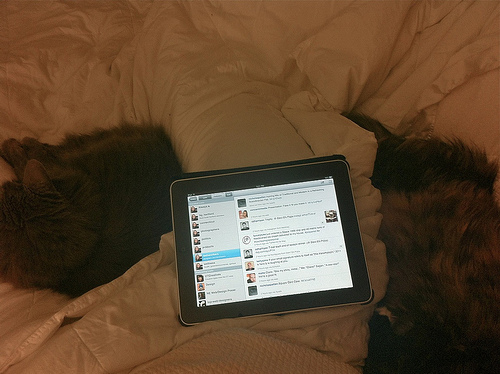<image>
Is the cat next to the ipad? Yes. The cat is positioned adjacent to the ipad, located nearby in the same general area. Where is the tablet in relation to the bed? Is it in front of the bed? No. The tablet is not in front of the bed. The spatial positioning shows a different relationship between these objects. 